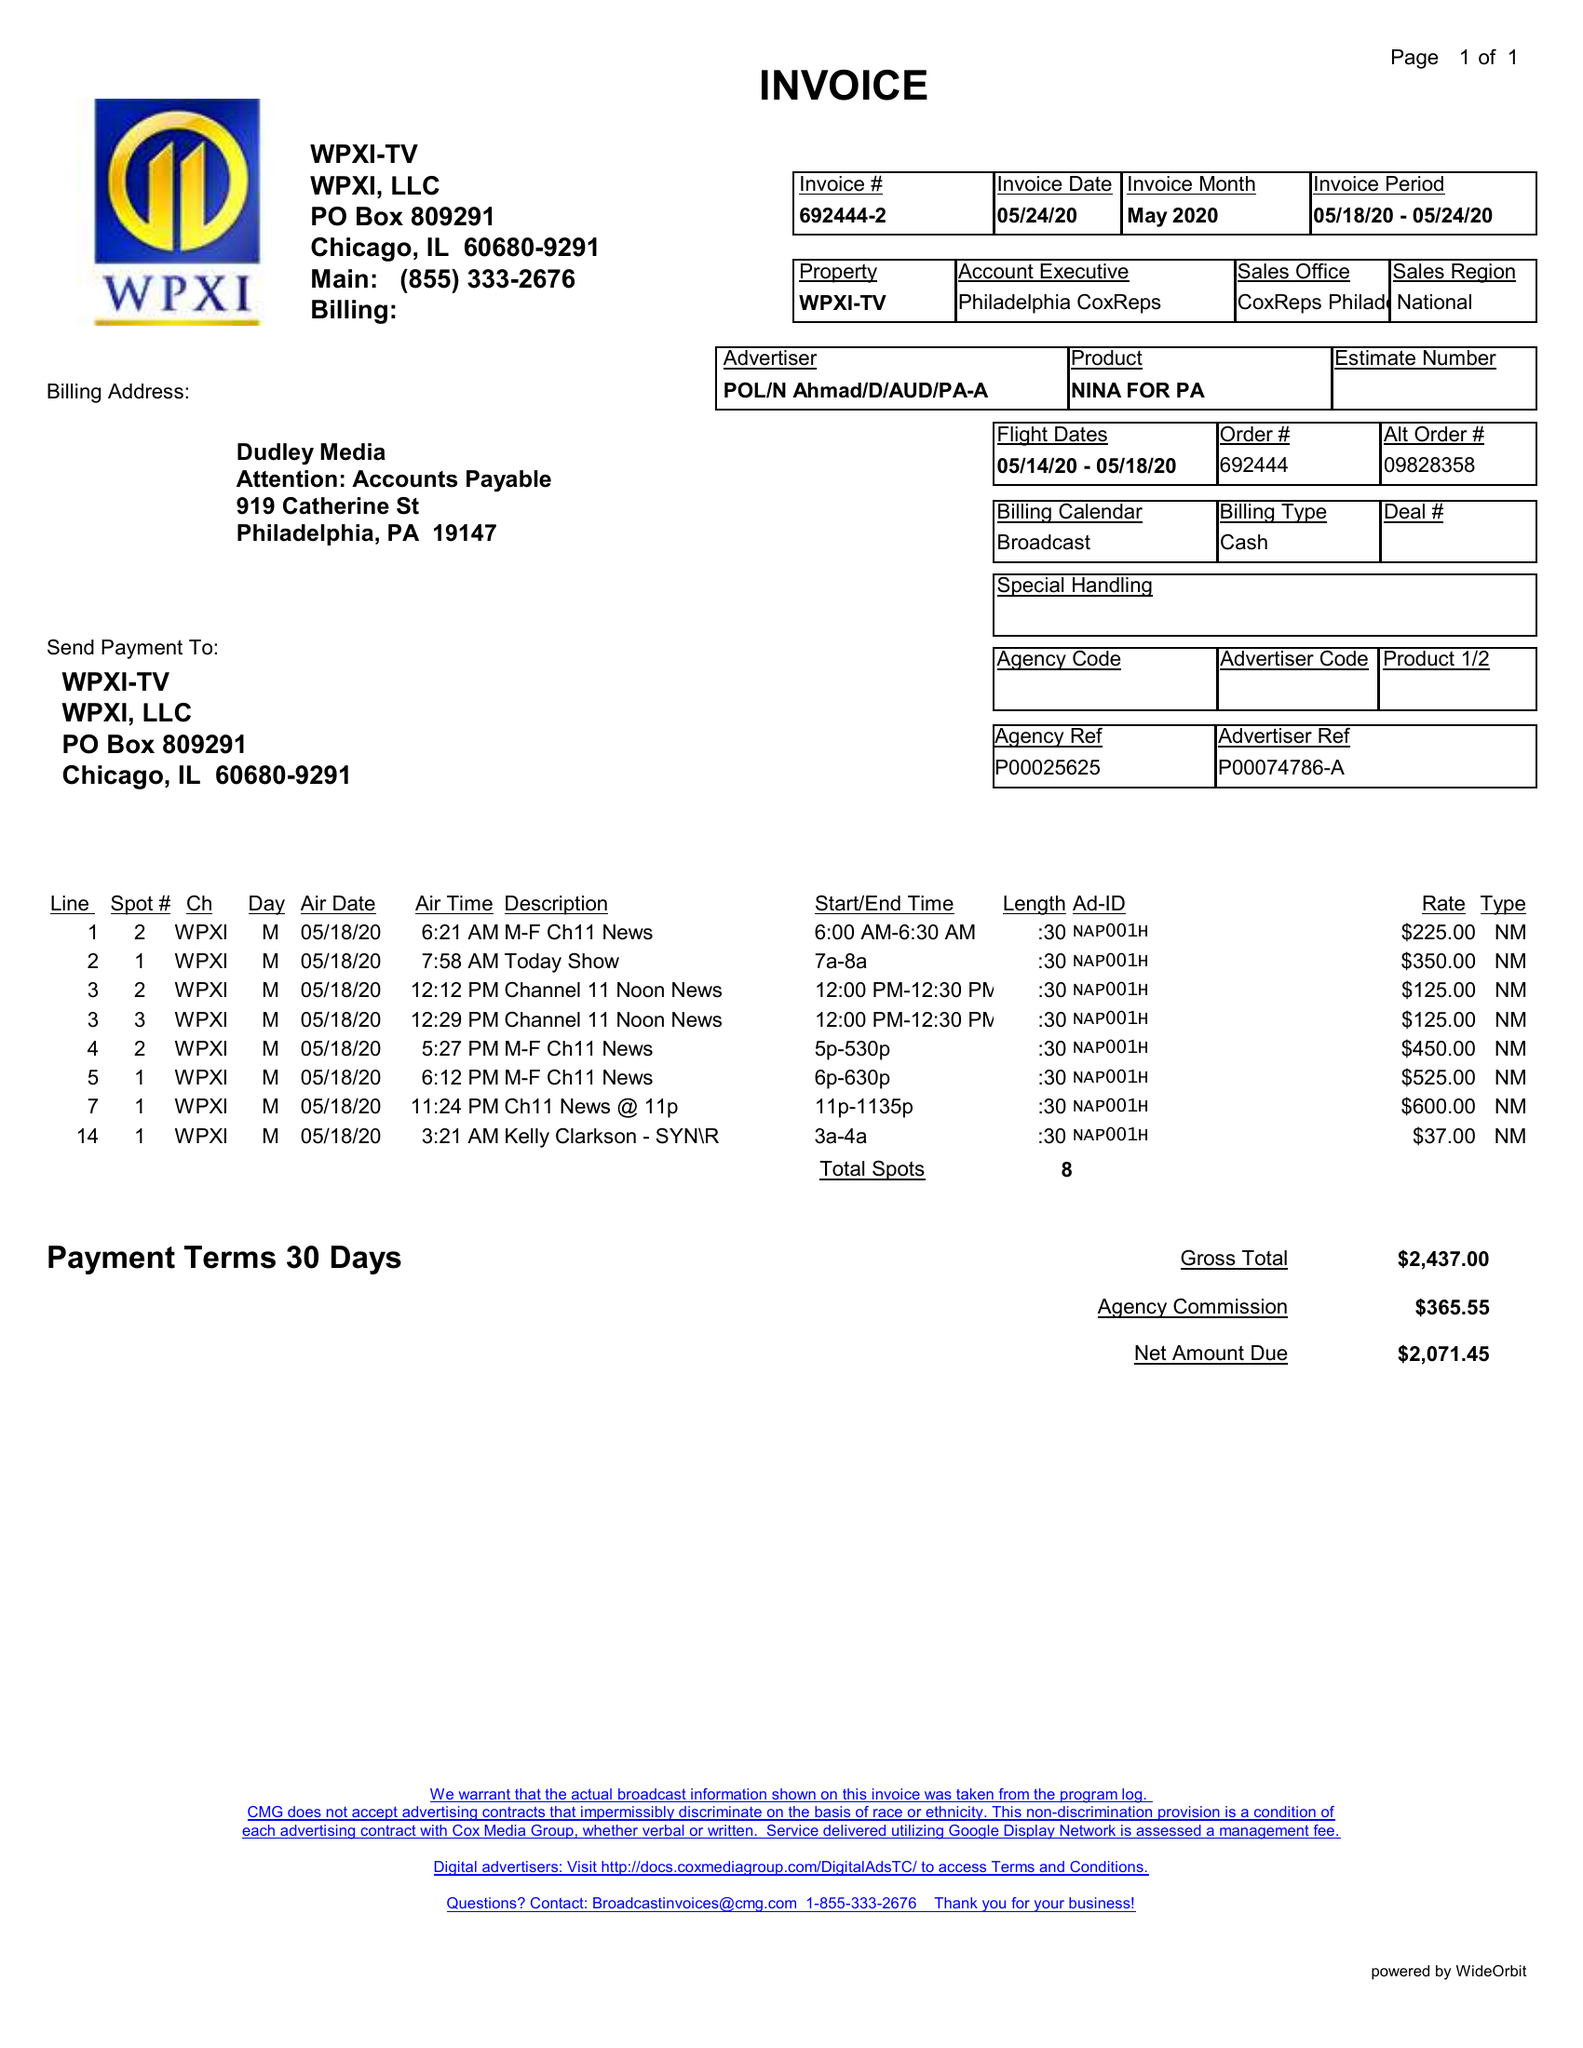What is the value for the advertiser?
Answer the question using a single word or phrase. POL/NAHMAD/D/AUD/PA-A 